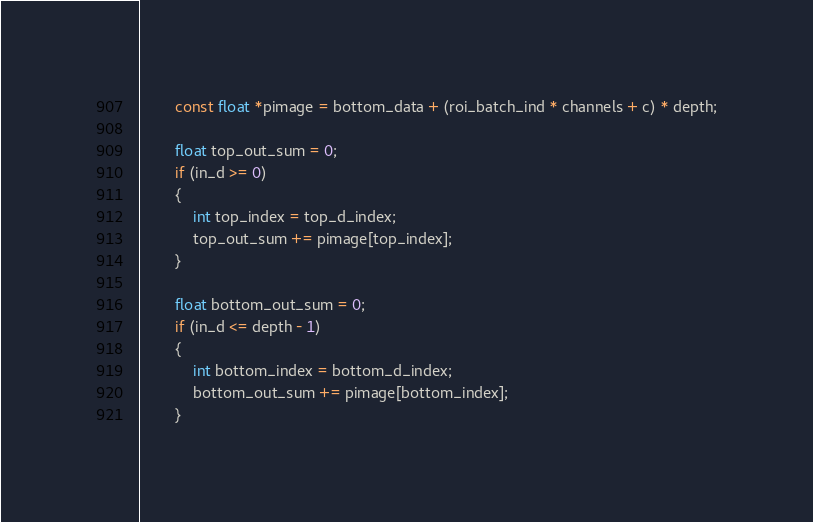Convert code to text. <code><loc_0><loc_0><loc_500><loc_500><_Cuda_>        const float *pimage = bottom_data + (roi_batch_ind * channels + c) * depth;

        float top_out_sum = 0;
        if (in_d >= 0)
        {
            int top_index = top_d_index;
            top_out_sum += pimage[top_index];
        }

        float bottom_out_sum = 0;
        if (in_d <= depth - 1)
        {
            int bottom_index = bottom_d_index;
            bottom_out_sum += pimage[bottom_index];
        }
</code> 